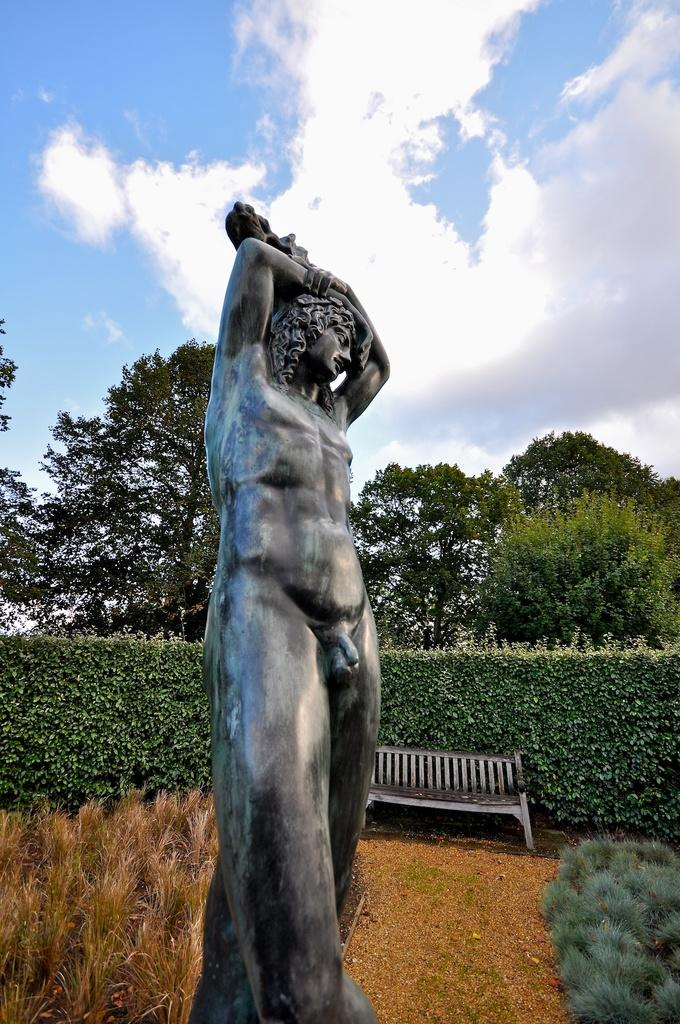What is the main subject in the image? There is a statue in the image. What type of furniture can be seen in the background of the image? There is a sofa in the background of the image. What type of natural vegetation is visible in the background of the image? There are trees in the background of the image. What type of natural phenomena can be seen in the background of the image? There are clouds in the background of the image. What part of the natural environment is visible in the background of the image? The sky is visible in the background of the image. What type of riddle can be seen etched into the statue in the image? There is no riddle visible on the statue in the image. What type of flesh can be seen on the statue in the image? The statue is an inanimate object and does not have flesh. What type of snack is being served in the image? There is no snack, such as popcorn, present in the image. 